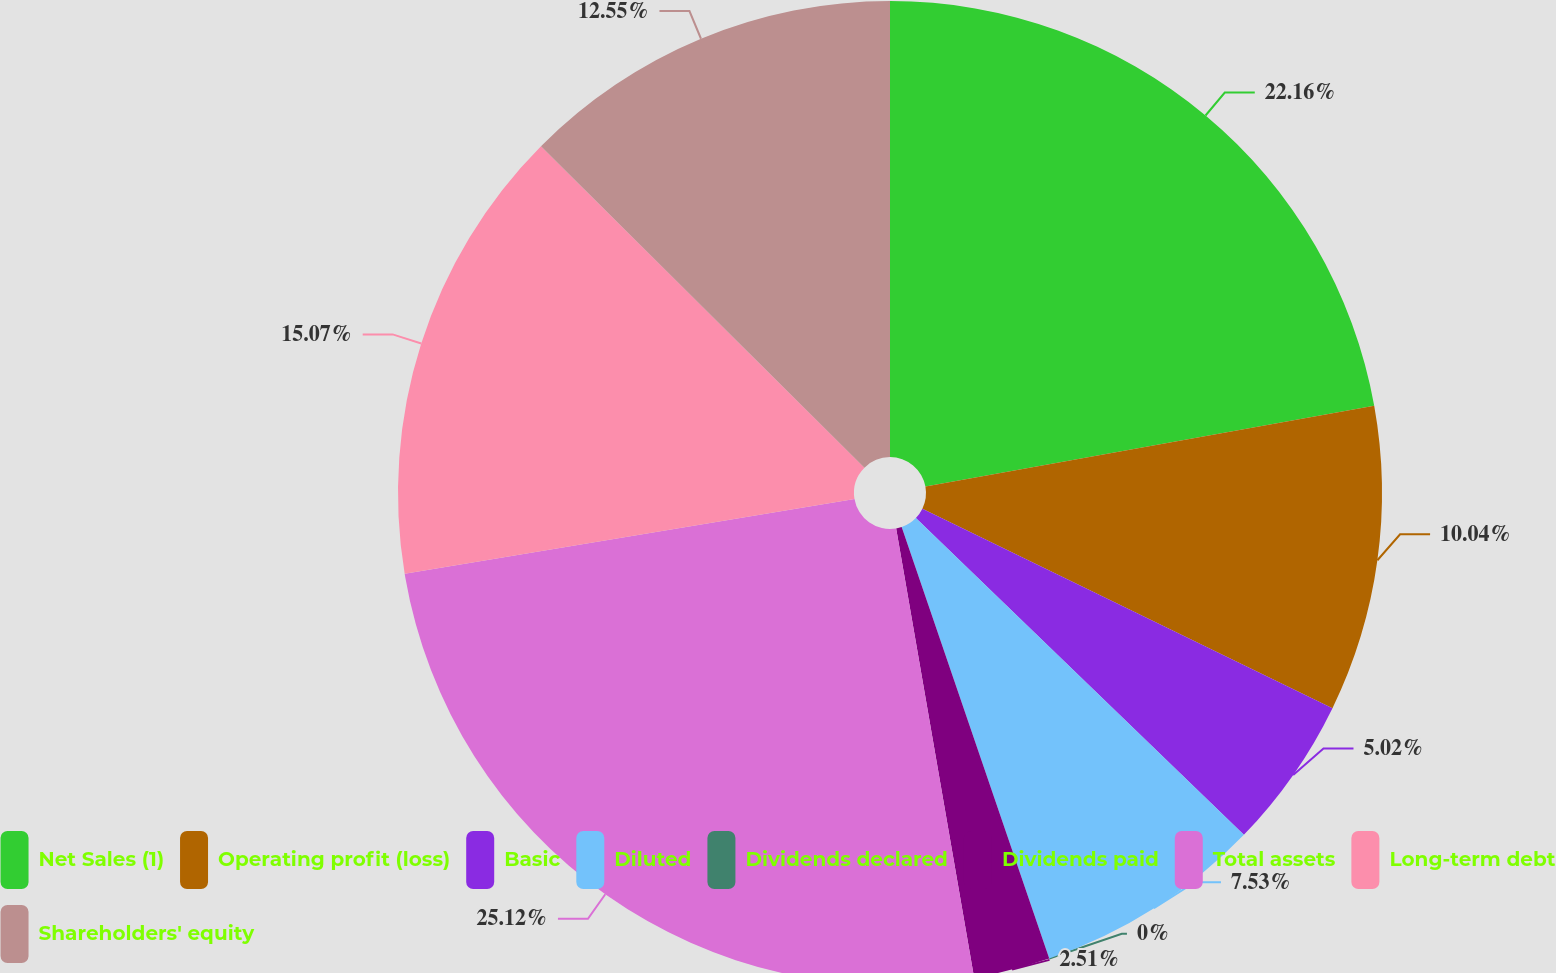Convert chart. <chart><loc_0><loc_0><loc_500><loc_500><pie_chart><fcel>Net Sales (1)<fcel>Operating profit (loss)<fcel>Basic<fcel>Diluted<fcel>Dividends declared<fcel>Dividends paid<fcel>Total assets<fcel>Long-term debt<fcel>Shareholders' equity<nl><fcel>22.16%<fcel>10.04%<fcel>5.02%<fcel>7.53%<fcel>0.0%<fcel>2.51%<fcel>25.11%<fcel>15.07%<fcel>12.55%<nl></chart> 